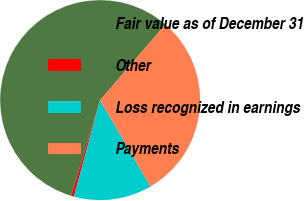<chart> <loc_0><loc_0><loc_500><loc_500><pie_chart><fcel>Fair value as of December 31<fcel>Other<fcel>Loss recognized in earnings<fcel>Payments<nl><fcel>56.66%<fcel>0.45%<fcel>12.64%<fcel>30.25%<nl></chart> 